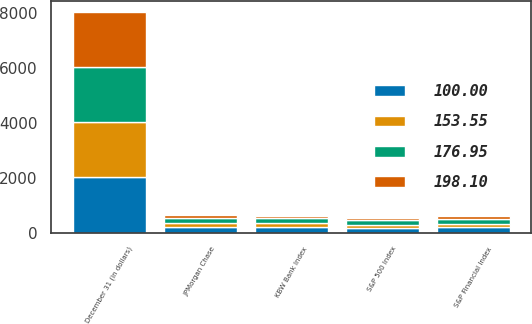<chart> <loc_0><loc_0><loc_500><loc_500><stacked_bar_chart><ecel><fcel>December 31 (in dollars)<fcel>JPMorgan Chase<fcel>KBW Bank Index<fcel>S&P Financial Index<fcel>S&P 500 Index<nl><fcel>198.1<fcel>2011<fcel>100<fcel>100<fcel>100<fcel>100<nl><fcel>153.55<fcel>2012<fcel>136.18<fcel>133.03<fcel>128.75<fcel>115.99<nl><fcel>176.95<fcel>2013<fcel>186.17<fcel>183.26<fcel>174.57<fcel>153.55<nl><fcel>100<fcel>2014<fcel>204.57<fcel>200.42<fcel>201.06<fcel>174.55<nl></chart> 